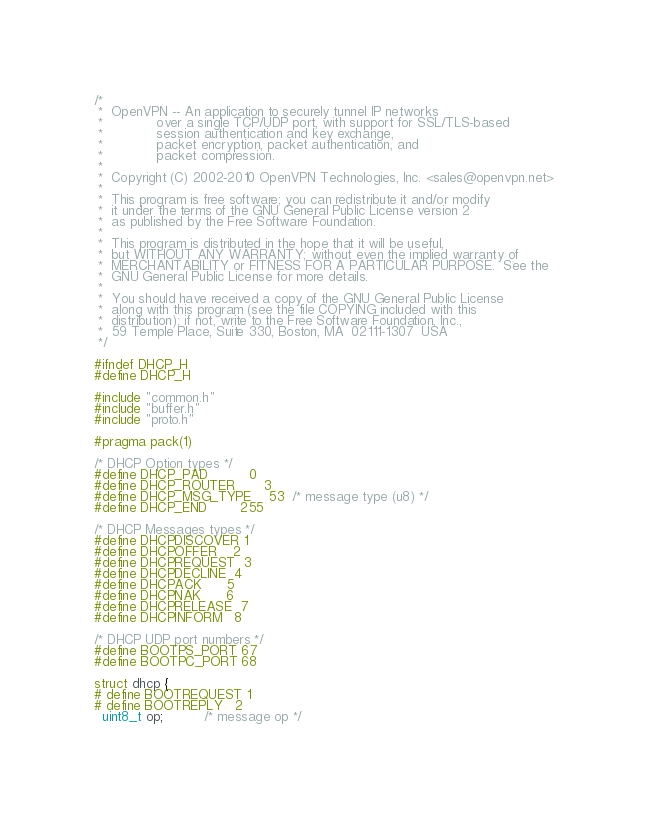<code> <loc_0><loc_0><loc_500><loc_500><_C_>/*
 *  OpenVPN -- An application to securely tunnel IP networks
 *             over a single TCP/UDP port, with support for SSL/TLS-based
 *             session authentication and key exchange,
 *             packet encryption, packet authentication, and
 *             packet compression.
 *
 *  Copyright (C) 2002-2010 OpenVPN Technologies, Inc. <sales@openvpn.net>
 *
 *  This program is free software; you can redistribute it and/or modify
 *  it under the terms of the GNU General Public License version 2
 *  as published by the Free Software Foundation.
 *
 *  This program is distributed in the hope that it will be useful,
 *  but WITHOUT ANY WARRANTY; without even the implied warranty of
 *  MERCHANTABILITY or FITNESS FOR A PARTICULAR PURPOSE.  See the
 *  GNU General Public License for more details.
 *
 *  You should have received a copy of the GNU General Public License
 *  along with this program (see the file COPYING included with this
 *  distribution); if not, write to the Free Software Foundation, Inc.,
 *  59 Temple Place, Suite 330, Boston, MA  02111-1307  USA
 */

#ifndef DHCP_H
#define DHCP_H

#include "common.h"
#include "buffer.h"
#include "proto.h"

#pragma pack(1)

/* DHCP Option types */
#define DHCP_PAD          0
#define DHCP_ROUTER       3
#define DHCP_MSG_TYPE    53  /* message type (u8) */
#define DHCP_END        255

/* DHCP Messages types */
#define DHCPDISCOVER 1
#define DHCPOFFER    2
#define DHCPREQUEST  3
#define DHCPDECLINE  4
#define DHCPACK      5
#define DHCPNAK      6
#define DHCPRELEASE  7
#define DHCPINFORM   8

/* DHCP UDP port numbers */
#define BOOTPS_PORT 67
#define BOOTPC_PORT 68

struct dhcp {
# define BOOTREQUEST 1
# define BOOTREPLY   2
  uint8_t op;          /* message op */
</code> 